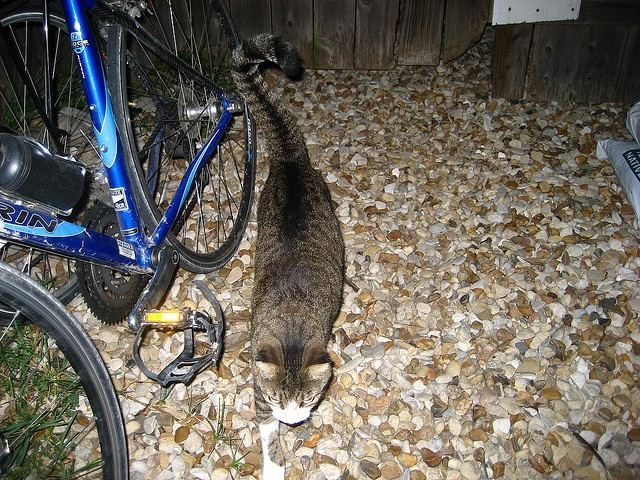Describe the objects in this image and their specific colors. I can see bicycle in black, gray, darkgray, and navy tones, cat in black and gray tones, and bottle in black, gray, and darkblue tones in this image. 